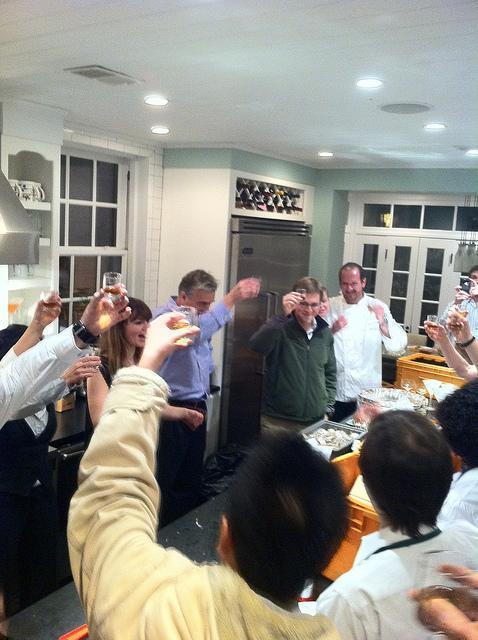How many people are visible?
Give a very brief answer. 10. How many motorcycles are here?
Give a very brief answer. 0. 